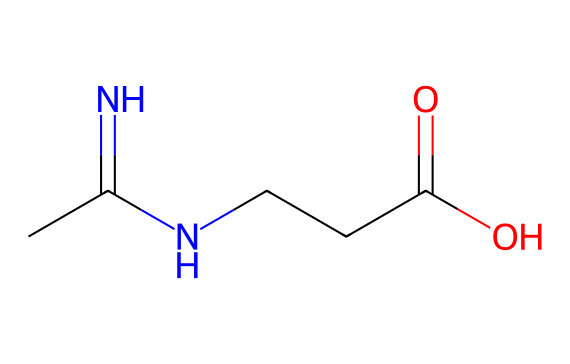how many nitrogen atoms are present in creatine? The chemical structure shows that there are two nitrogen atoms, which can be counted from the SMILES notation (N counts).
Answer: two what is the molecular formula of creatine based on its structure? By analyzing the SMILES representation CC(=N)NCCC(=O)O, we can derive the molecular formula, which includes 4 carbon (C), 9 hydrogen (H), 2 nitrogen (N), and 2 oxygen (O) atoms.
Answer: C4H9N3O2 what is the primary functional group in creatine? The carboxyl group (-COOH) is present in the molecular structure, which appears as C(=O)O in the SMILES notation. This group is characteristic of acids.
Answer: carboxylic acid which part of the molecule serves to bind with phosphate in ATP synthesis? The presence of the nitrogen atoms in the structure is where creatine can undergo phosphorylation to connect with phosphate groups during ATP synthesis. This is because nitrogen serves as a nucleophile in biochemical reactions.
Answer: nitrogen is creatine a polar or nonpolar molecule? The presence of the carboxylic acid group and the nitrogen atoms contribute to its polar character, indicating it may interact well with water, thus making it a polar molecule.
Answer: polar what role does creatine play in muscle metabolism? Creatine stores high-energy phosphate groups that can be transferred to ADP to regenerate ATP, providing energy during intense muscular activity.
Answer: energy carrier 